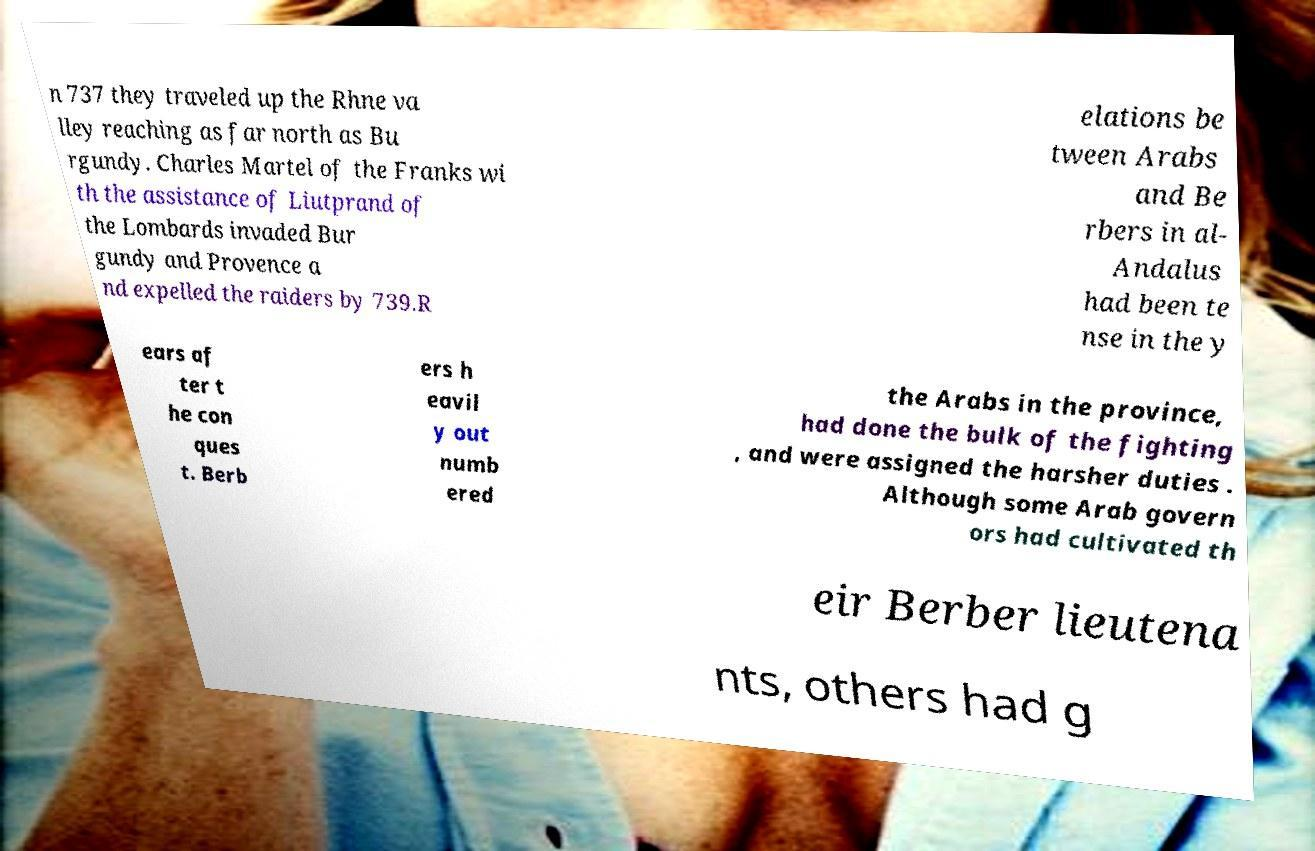There's text embedded in this image that I need extracted. Can you transcribe it verbatim? n 737 they traveled up the Rhne va lley reaching as far north as Bu rgundy. Charles Martel of the Franks wi th the assistance of Liutprand of the Lombards invaded Bur gundy and Provence a nd expelled the raiders by 739.R elations be tween Arabs and Be rbers in al- Andalus had been te nse in the y ears af ter t he con ques t. Berb ers h eavil y out numb ered the Arabs in the province, had done the bulk of the fighting , and were assigned the harsher duties . Although some Arab govern ors had cultivated th eir Berber lieutena nts, others had g 